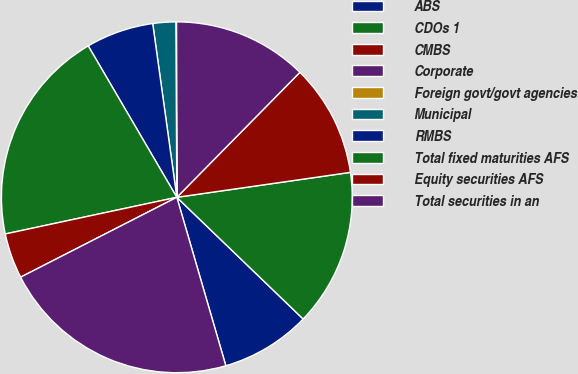Convert chart. <chart><loc_0><loc_0><loc_500><loc_500><pie_chart><fcel>ABS<fcel>CDOs 1<fcel>CMBS<fcel>Corporate<fcel>Foreign govt/govt agencies<fcel>Municipal<fcel>RMBS<fcel>Total fixed maturities AFS<fcel>Equity securities AFS<fcel>Total securities in an<nl><fcel>8.29%<fcel>14.47%<fcel>10.35%<fcel>12.41%<fcel>0.05%<fcel>2.11%<fcel>6.23%<fcel>19.92%<fcel>4.17%<fcel>21.98%<nl></chart> 